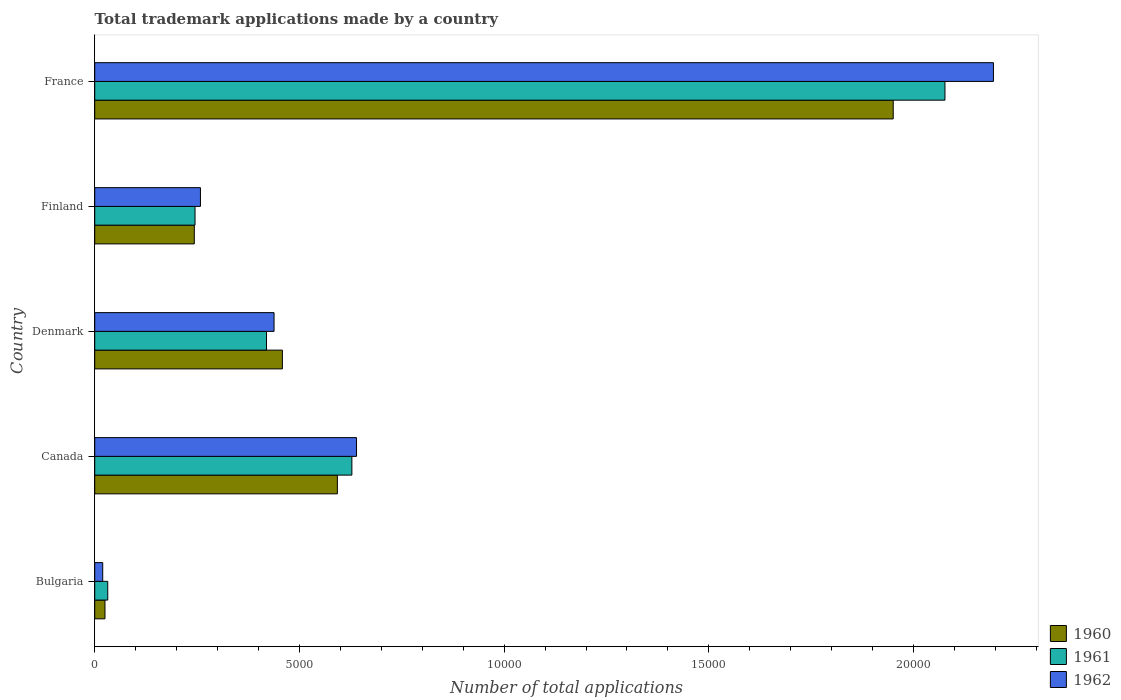How many groups of bars are there?
Provide a succinct answer. 5. How many bars are there on the 4th tick from the top?
Offer a very short reply. 3. How many bars are there on the 3rd tick from the bottom?
Make the answer very short. 3. What is the number of applications made by in 1961 in Canada?
Provide a succinct answer. 6281. Across all countries, what is the maximum number of applications made by in 1961?
Offer a terse response. 2.08e+04. Across all countries, what is the minimum number of applications made by in 1961?
Keep it short and to the point. 318. What is the total number of applications made by in 1961 in the graph?
Your answer should be compact. 3.40e+04. What is the difference between the number of applications made by in 1960 in Denmark and that in Finland?
Your answer should be compact. 2152. What is the difference between the number of applications made by in 1961 in Denmark and the number of applications made by in 1960 in France?
Your answer should be compact. -1.53e+04. What is the average number of applications made by in 1960 per country?
Your answer should be very brief. 6539.4. What is the difference between the number of applications made by in 1961 and number of applications made by in 1962 in France?
Provide a succinct answer. -1184. In how many countries, is the number of applications made by in 1961 greater than 22000 ?
Offer a terse response. 0. What is the ratio of the number of applications made by in 1962 in Bulgaria to that in Denmark?
Offer a very short reply. 0.04. Is the number of applications made by in 1961 in Denmark less than that in Finland?
Offer a terse response. No. What is the difference between the highest and the second highest number of applications made by in 1962?
Ensure brevity in your answer.  1.56e+04. What is the difference between the highest and the lowest number of applications made by in 1962?
Ensure brevity in your answer.  2.18e+04. In how many countries, is the number of applications made by in 1962 greater than the average number of applications made by in 1962 taken over all countries?
Your answer should be compact. 1. What does the 1st bar from the top in Canada represents?
Offer a very short reply. 1962. Is it the case that in every country, the sum of the number of applications made by in 1962 and number of applications made by in 1960 is greater than the number of applications made by in 1961?
Ensure brevity in your answer.  Yes. What is the difference between two consecutive major ticks on the X-axis?
Provide a succinct answer. 5000. Are the values on the major ticks of X-axis written in scientific E-notation?
Make the answer very short. No. Where does the legend appear in the graph?
Offer a very short reply. Bottom right. How many legend labels are there?
Offer a very short reply. 3. How are the legend labels stacked?
Your response must be concise. Vertical. What is the title of the graph?
Ensure brevity in your answer.  Total trademark applications made by a country. Does "1994" appear as one of the legend labels in the graph?
Your answer should be very brief. No. What is the label or title of the X-axis?
Ensure brevity in your answer.  Number of total applications. What is the Number of total applications of 1960 in Bulgaria?
Make the answer very short. 250. What is the Number of total applications of 1961 in Bulgaria?
Offer a very short reply. 318. What is the Number of total applications of 1962 in Bulgaria?
Your response must be concise. 195. What is the Number of total applications of 1960 in Canada?
Your answer should be very brief. 5927. What is the Number of total applications in 1961 in Canada?
Offer a terse response. 6281. What is the Number of total applications in 1962 in Canada?
Offer a very short reply. 6395. What is the Number of total applications of 1960 in Denmark?
Your response must be concise. 4584. What is the Number of total applications of 1961 in Denmark?
Ensure brevity in your answer.  4196. What is the Number of total applications of 1962 in Denmark?
Your answer should be compact. 4380. What is the Number of total applications of 1960 in Finland?
Give a very brief answer. 2432. What is the Number of total applications in 1961 in Finland?
Your answer should be compact. 2450. What is the Number of total applications of 1962 in Finland?
Provide a succinct answer. 2582. What is the Number of total applications of 1960 in France?
Make the answer very short. 1.95e+04. What is the Number of total applications of 1961 in France?
Provide a short and direct response. 2.08e+04. What is the Number of total applications in 1962 in France?
Your answer should be very brief. 2.20e+04. Across all countries, what is the maximum Number of total applications of 1960?
Keep it short and to the point. 1.95e+04. Across all countries, what is the maximum Number of total applications in 1961?
Keep it short and to the point. 2.08e+04. Across all countries, what is the maximum Number of total applications of 1962?
Your response must be concise. 2.20e+04. Across all countries, what is the minimum Number of total applications of 1960?
Your answer should be compact. 250. Across all countries, what is the minimum Number of total applications of 1961?
Offer a very short reply. 318. Across all countries, what is the minimum Number of total applications in 1962?
Offer a very short reply. 195. What is the total Number of total applications of 1960 in the graph?
Offer a very short reply. 3.27e+04. What is the total Number of total applications of 1961 in the graph?
Your response must be concise. 3.40e+04. What is the total Number of total applications of 1962 in the graph?
Your answer should be compact. 3.55e+04. What is the difference between the Number of total applications of 1960 in Bulgaria and that in Canada?
Make the answer very short. -5677. What is the difference between the Number of total applications of 1961 in Bulgaria and that in Canada?
Your answer should be very brief. -5963. What is the difference between the Number of total applications of 1962 in Bulgaria and that in Canada?
Your response must be concise. -6200. What is the difference between the Number of total applications in 1960 in Bulgaria and that in Denmark?
Offer a very short reply. -4334. What is the difference between the Number of total applications of 1961 in Bulgaria and that in Denmark?
Give a very brief answer. -3878. What is the difference between the Number of total applications of 1962 in Bulgaria and that in Denmark?
Provide a short and direct response. -4185. What is the difference between the Number of total applications of 1960 in Bulgaria and that in Finland?
Ensure brevity in your answer.  -2182. What is the difference between the Number of total applications in 1961 in Bulgaria and that in Finland?
Make the answer very short. -2132. What is the difference between the Number of total applications in 1962 in Bulgaria and that in Finland?
Ensure brevity in your answer.  -2387. What is the difference between the Number of total applications of 1960 in Bulgaria and that in France?
Your response must be concise. -1.93e+04. What is the difference between the Number of total applications in 1961 in Bulgaria and that in France?
Your answer should be very brief. -2.04e+04. What is the difference between the Number of total applications in 1962 in Bulgaria and that in France?
Ensure brevity in your answer.  -2.18e+04. What is the difference between the Number of total applications of 1960 in Canada and that in Denmark?
Keep it short and to the point. 1343. What is the difference between the Number of total applications of 1961 in Canada and that in Denmark?
Provide a short and direct response. 2085. What is the difference between the Number of total applications of 1962 in Canada and that in Denmark?
Offer a terse response. 2015. What is the difference between the Number of total applications of 1960 in Canada and that in Finland?
Make the answer very short. 3495. What is the difference between the Number of total applications of 1961 in Canada and that in Finland?
Offer a terse response. 3831. What is the difference between the Number of total applications in 1962 in Canada and that in Finland?
Offer a terse response. 3813. What is the difference between the Number of total applications of 1960 in Canada and that in France?
Provide a succinct answer. -1.36e+04. What is the difference between the Number of total applications of 1961 in Canada and that in France?
Provide a short and direct response. -1.45e+04. What is the difference between the Number of total applications of 1962 in Canada and that in France?
Provide a succinct answer. -1.56e+04. What is the difference between the Number of total applications of 1960 in Denmark and that in Finland?
Your answer should be very brief. 2152. What is the difference between the Number of total applications of 1961 in Denmark and that in Finland?
Provide a short and direct response. 1746. What is the difference between the Number of total applications of 1962 in Denmark and that in Finland?
Your answer should be compact. 1798. What is the difference between the Number of total applications of 1960 in Denmark and that in France?
Your response must be concise. -1.49e+04. What is the difference between the Number of total applications in 1961 in Denmark and that in France?
Provide a short and direct response. -1.66e+04. What is the difference between the Number of total applications in 1962 in Denmark and that in France?
Ensure brevity in your answer.  -1.76e+04. What is the difference between the Number of total applications in 1960 in Finland and that in France?
Offer a terse response. -1.71e+04. What is the difference between the Number of total applications of 1961 in Finland and that in France?
Your answer should be very brief. -1.83e+04. What is the difference between the Number of total applications of 1962 in Finland and that in France?
Your response must be concise. -1.94e+04. What is the difference between the Number of total applications of 1960 in Bulgaria and the Number of total applications of 1961 in Canada?
Keep it short and to the point. -6031. What is the difference between the Number of total applications of 1960 in Bulgaria and the Number of total applications of 1962 in Canada?
Your answer should be compact. -6145. What is the difference between the Number of total applications of 1961 in Bulgaria and the Number of total applications of 1962 in Canada?
Keep it short and to the point. -6077. What is the difference between the Number of total applications of 1960 in Bulgaria and the Number of total applications of 1961 in Denmark?
Keep it short and to the point. -3946. What is the difference between the Number of total applications of 1960 in Bulgaria and the Number of total applications of 1962 in Denmark?
Keep it short and to the point. -4130. What is the difference between the Number of total applications of 1961 in Bulgaria and the Number of total applications of 1962 in Denmark?
Give a very brief answer. -4062. What is the difference between the Number of total applications of 1960 in Bulgaria and the Number of total applications of 1961 in Finland?
Give a very brief answer. -2200. What is the difference between the Number of total applications in 1960 in Bulgaria and the Number of total applications in 1962 in Finland?
Your response must be concise. -2332. What is the difference between the Number of total applications in 1961 in Bulgaria and the Number of total applications in 1962 in Finland?
Your answer should be very brief. -2264. What is the difference between the Number of total applications in 1960 in Bulgaria and the Number of total applications in 1961 in France?
Your response must be concise. -2.05e+04. What is the difference between the Number of total applications in 1960 in Bulgaria and the Number of total applications in 1962 in France?
Offer a very short reply. -2.17e+04. What is the difference between the Number of total applications of 1961 in Bulgaria and the Number of total applications of 1962 in France?
Offer a terse response. -2.16e+04. What is the difference between the Number of total applications of 1960 in Canada and the Number of total applications of 1961 in Denmark?
Offer a terse response. 1731. What is the difference between the Number of total applications of 1960 in Canada and the Number of total applications of 1962 in Denmark?
Provide a short and direct response. 1547. What is the difference between the Number of total applications of 1961 in Canada and the Number of total applications of 1962 in Denmark?
Provide a succinct answer. 1901. What is the difference between the Number of total applications in 1960 in Canada and the Number of total applications in 1961 in Finland?
Keep it short and to the point. 3477. What is the difference between the Number of total applications of 1960 in Canada and the Number of total applications of 1962 in Finland?
Your response must be concise. 3345. What is the difference between the Number of total applications of 1961 in Canada and the Number of total applications of 1962 in Finland?
Your answer should be very brief. 3699. What is the difference between the Number of total applications in 1960 in Canada and the Number of total applications in 1961 in France?
Give a very brief answer. -1.48e+04. What is the difference between the Number of total applications of 1960 in Canada and the Number of total applications of 1962 in France?
Make the answer very short. -1.60e+04. What is the difference between the Number of total applications in 1961 in Canada and the Number of total applications in 1962 in France?
Offer a terse response. -1.57e+04. What is the difference between the Number of total applications in 1960 in Denmark and the Number of total applications in 1961 in Finland?
Your response must be concise. 2134. What is the difference between the Number of total applications of 1960 in Denmark and the Number of total applications of 1962 in Finland?
Your answer should be very brief. 2002. What is the difference between the Number of total applications in 1961 in Denmark and the Number of total applications in 1962 in Finland?
Your response must be concise. 1614. What is the difference between the Number of total applications of 1960 in Denmark and the Number of total applications of 1961 in France?
Make the answer very short. -1.62e+04. What is the difference between the Number of total applications in 1960 in Denmark and the Number of total applications in 1962 in France?
Your answer should be very brief. -1.74e+04. What is the difference between the Number of total applications in 1961 in Denmark and the Number of total applications in 1962 in France?
Provide a short and direct response. -1.78e+04. What is the difference between the Number of total applications of 1960 in Finland and the Number of total applications of 1961 in France?
Your answer should be very brief. -1.83e+04. What is the difference between the Number of total applications in 1960 in Finland and the Number of total applications in 1962 in France?
Your answer should be very brief. -1.95e+04. What is the difference between the Number of total applications of 1961 in Finland and the Number of total applications of 1962 in France?
Your response must be concise. -1.95e+04. What is the average Number of total applications of 1960 per country?
Offer a terse response. 6539.4. What is the average Number of total applications of 1961 per country?
Your answer should be compact. 6802.6. What is the average Number of total applications of 1962 per country?
Offer a terse response. 7100.8. What is the difference between the Number of total applications in 1960 and Number of total applications in 1961 in Bulgaria?
Provide a succinct answer. -68. What is the difference between the Number of total applications of 1961 and Number of total applications of 1962 in Bulgaria?
Provide a short and direct response. 123. What is the difference between the Number of total applications in 1960 and Number of total applications in 1961 in Canada?
Ensure brevity in your answer.  -354. What is the difference between the Number of total applications of 1960 and Number of total applications of 1962 in Canada?
Give a very brief answer. -468. What is the difference between the Number of total applications of 1961 and Number of total applications of 1962 in Canada?
Ensure brevity in your answer.  -114. What is the difference between the Number of total applications in 1960 and Number of total applications in 1961 in Denmark?
Ensure brevity in your answer.  388. What is the difference between the Number of total applications of 1960 and Number of total applications of 1962 in Denmark?
Your answer should be compact. 204. What is the difference between the Number of total applications in 1961 and Number of total applications in 1962 in Denmark?
Your answer should be very brief. -184. What is the difference between the Number of total applications of 1960 and Number of total applications of 1961 in Finland?
Your answer should be compact. -18. What is the difference between the Number of total applications in 1960 and Number of total applications in 1962 in Finland?
Give a very brief answer. -150. What is the difference between the Number of total applications in 1961 and Number of total applications in 1962 in Finland?
Your response must be concise. -132. What is the difference between the Number of total applications in 1960 and Number of total applications in 1961 in France?
Your answer should be compact. -1264. What is the difference between the Number of total applications of 1960 and Number of total applications of 1962 in France?
Your response must be concise. -2448. What is the difference between the Number of total applications of 1961 and Number of total applications of 1962 in France?
Give a very brief answer. -1184. What is the ratio of the Number of total applications of 1960 in Bulgaria to that in Canada?
Ensure brevity in your answer.  0.04. What is the ratio of the Number of total applications of 1961 in Bulgaria to that in Canada?
Make the answer very short. 0.05. What is the ratio of the Number of total applications in 1962 in Bulgaria to that in Canada?
Keep it short and to the point. 0.03. What is the ratio of the Number of total applications in 1960 in Bulgaria to that in Denmark?
Provide a succinct answer. 0.05. What is the ratio of the Number of total applications of 1961 in Bulgaria to that in Denmark?
Ensure brevity in your answer.  0.08. What is the ratio of the Number of total applications in 1962 in Bulgaria to that in Denmark?
Your response must be concise. 0.04. What is the ratio of the Number of total applications of 1960 in Bulgaria to that in Finland?
Make the answer very short. 0.1. What is the ratio of the Number of total applications of 1961 in Bulgaria to that in Finland?
Your response must be concise. 0.13. What is the ratio of the Number of total applications in 1962 in Bulgaria to that in Finland?
Give a very brief answer. 0.08. What is the ratio of the Number of total applications of 1960 in Bulgaria to that in France?
Provide a short and direct response. 0.01. What is the ratio of the Number of total applications of 1961 in Bulgaria to that in France?
Ensure brevity in your answer.  0.02. What is the ratio of the Number of total applications of 1962 in Bulgaria to that in France?
Provide a short and direct response. 0.01. What is the ratio of the Number of total applications of 1960 in Canada to that in Denmark?
Make the answer very short. 1.29. What is the ratio of the Number of total applications of 1961 in Canada to that in Denmark?
Make the answer very short. 1.5. What is the ratio of the Number of total applications in 1962 in Canada to that in Denmark?
Offer a very short reply. 1.46. What is the ratio of the Number of total applications in 1960 in Canada to that in Finland?
Offer a very short reply. 2.44. What is the ratio of the Number of total applications in 1961 in Canada to that in Finland?
Offer a terse response. 2.56. What is the ratio of the Number of total applications of 1962 in Canada to that in Finland?
Give a very brief answer. 2.48. What is the ratio of the Number of total applications of 1960 in Canada to that in France?
Make the answer very short. 0.3. What is the ratio of the Number of total applications of 1961 in Canada to that in France?
Provide a succinct answer. 0.3. What is the ratio of the Number of total applications in 1962 in Canada to that in France?
Make the answer very short. 0.29. What is the ratio of the Number of total applications of 1960 in Denmark to that in Finland?
Keep it short and to the point. 1.88. What is the ratio of the Number of total applications in 1961 in Denmark to that in Finland?
Your answer should be compact. 1.71. What is the ratio of the Number of total applications in 1962 in Denmark to that in Finland?
Your response must be concise. 1.7. What is the ratio of the Number of total applications in 1960 in Denmark to that in France?
Provide a succinct answer. 0.23. What is the ratio of the Number of total applications of 1961 in Denmark to that in France?
Your answer should be compact. 0.2. What is the ratio of the Number of total applications of 1962 in Denmark to that in France?
Your answer should be compact. 0.2. What is the ratio of the Number of total applications in 1960 in Finland to that in France?
Offer a terse response. 0.12. What is the ratio of the Number of total applications in 1961 in Finland to that in France?
Your response must be concise. 0.12. What is the ratio of the Number of total applications of 1962 in Finland to that in France?
Your answer should be very brief. 0.12. What is the difference between the highest and the second highest Number of total applications of 1960?
Provide a short and direct response. 1.36e+04. What is the difference between the highest and the second highest Number of total applications in 1961?
Ensure brevity in your answer.  1.45e+04. What is the difference between the highest and the second highest Number of total applications of 1962?
Ensure brevity in your answer.  1.56e+04. What is the difference between the highest and the lowest Number of total applications in 1960?
Ensure brevity in your answer.  1.93e+04. What is the difference between the highest and the lowest Number of total applications in 1961?
Give a very brief answer. 2.04e+04. What is the difference between the highest and the lowest Number of total applications in 1962?
Provide a short and direct response. 2.18e+04. 